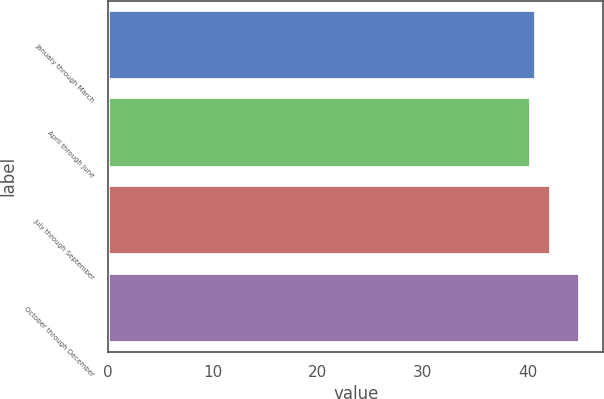Convert chart. <chart><loc_0><loc_0><loc_500><loc_500><bar_chart><fcel>January through March<fcel>April through June<fcel>July through September<fcel>October through December<nl><fcel>40.79<fcel>40.33<fcel>42.27<fcel>44.96<nl></chart> 